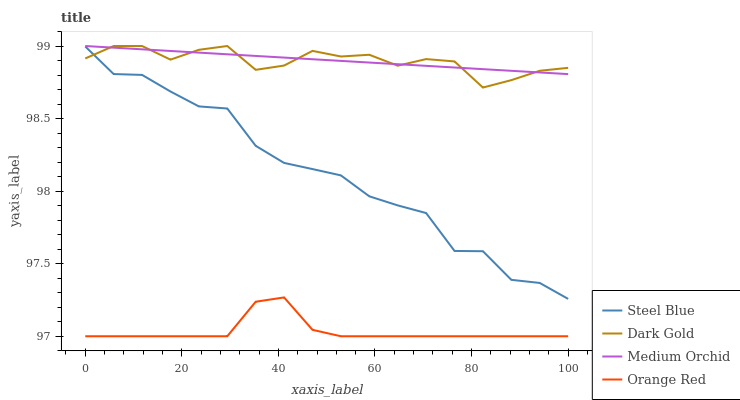Does Steel Blue have the minimum area under the curve?
Answer yes or no. No. Does Steel Blue have the maximum area under the curve?
Answer yes or no. No. Is Orange Red the smoothest?
Answer yes or no. No. Is Orange Red the roughest?
Answer yes or no. No. Does Steel Blue have the lowest value?
Answer yes or no. No. Does Steel Blue have the highest value?
Answer yes or no. No. Is Steel Blue less than Medium Orchid?
Answer yes or no. Yes. Is Medium Orchid greater than Steel Blue?
Answer yes or no. Yes. Does Steel Blue intersect Medium Orchid?
Answer yes or no. No. 